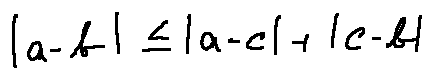Convert formula to latex. <formula><loc_0><loc_0><loc_500><loc_500>| a - b | \leq | a - c | + | c - b |</formula> 